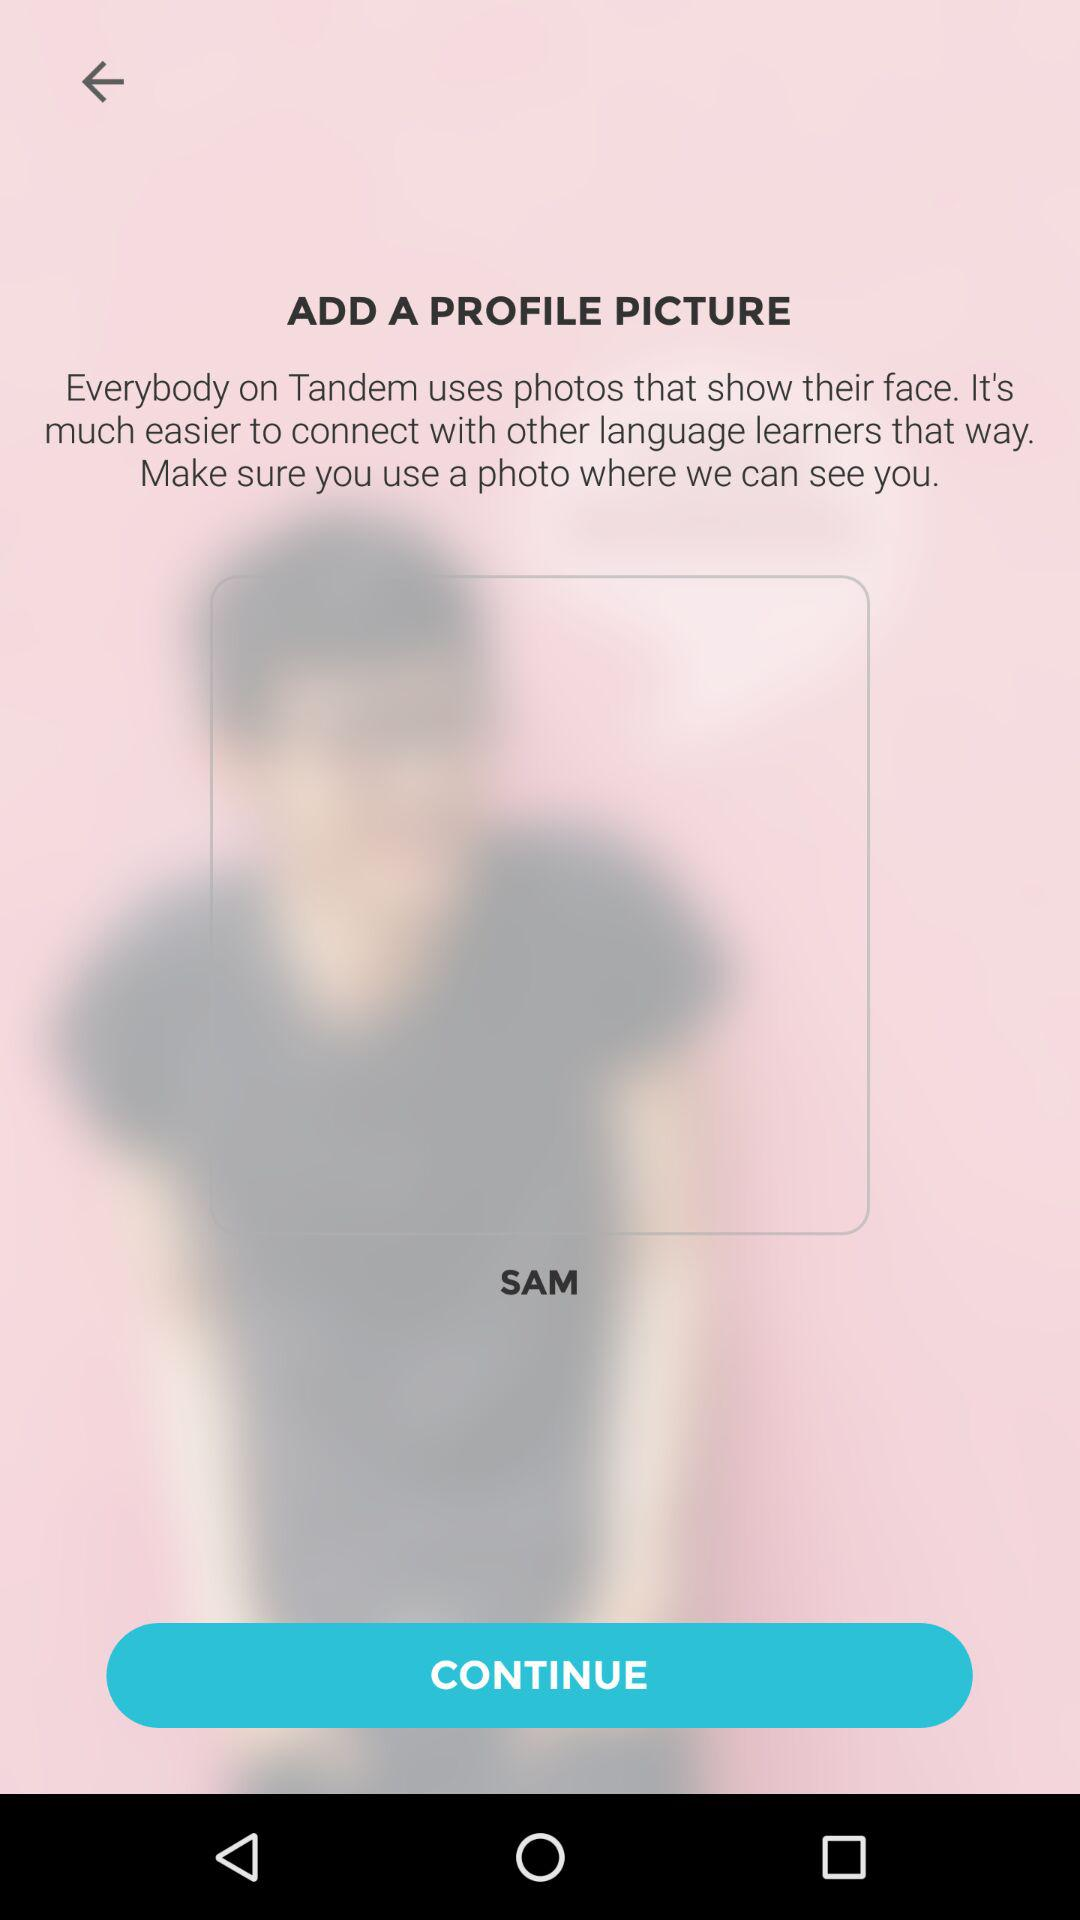What is the given name? The given name is Sam. 